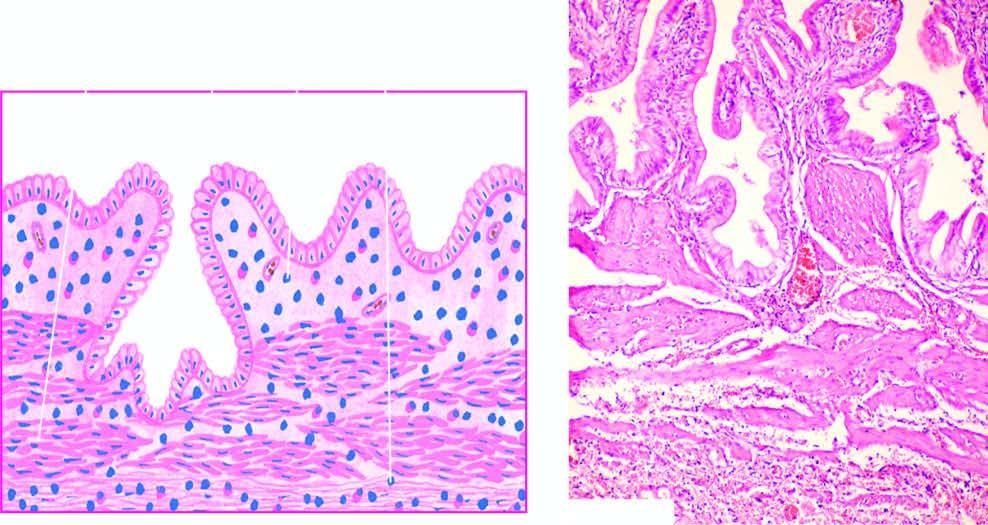s approximately 50 % of the soft tissue of the bone subepithelial and subserosal fibrosis and hypertrophy of muscularis?
Answer the question using a single word or phrase. No 